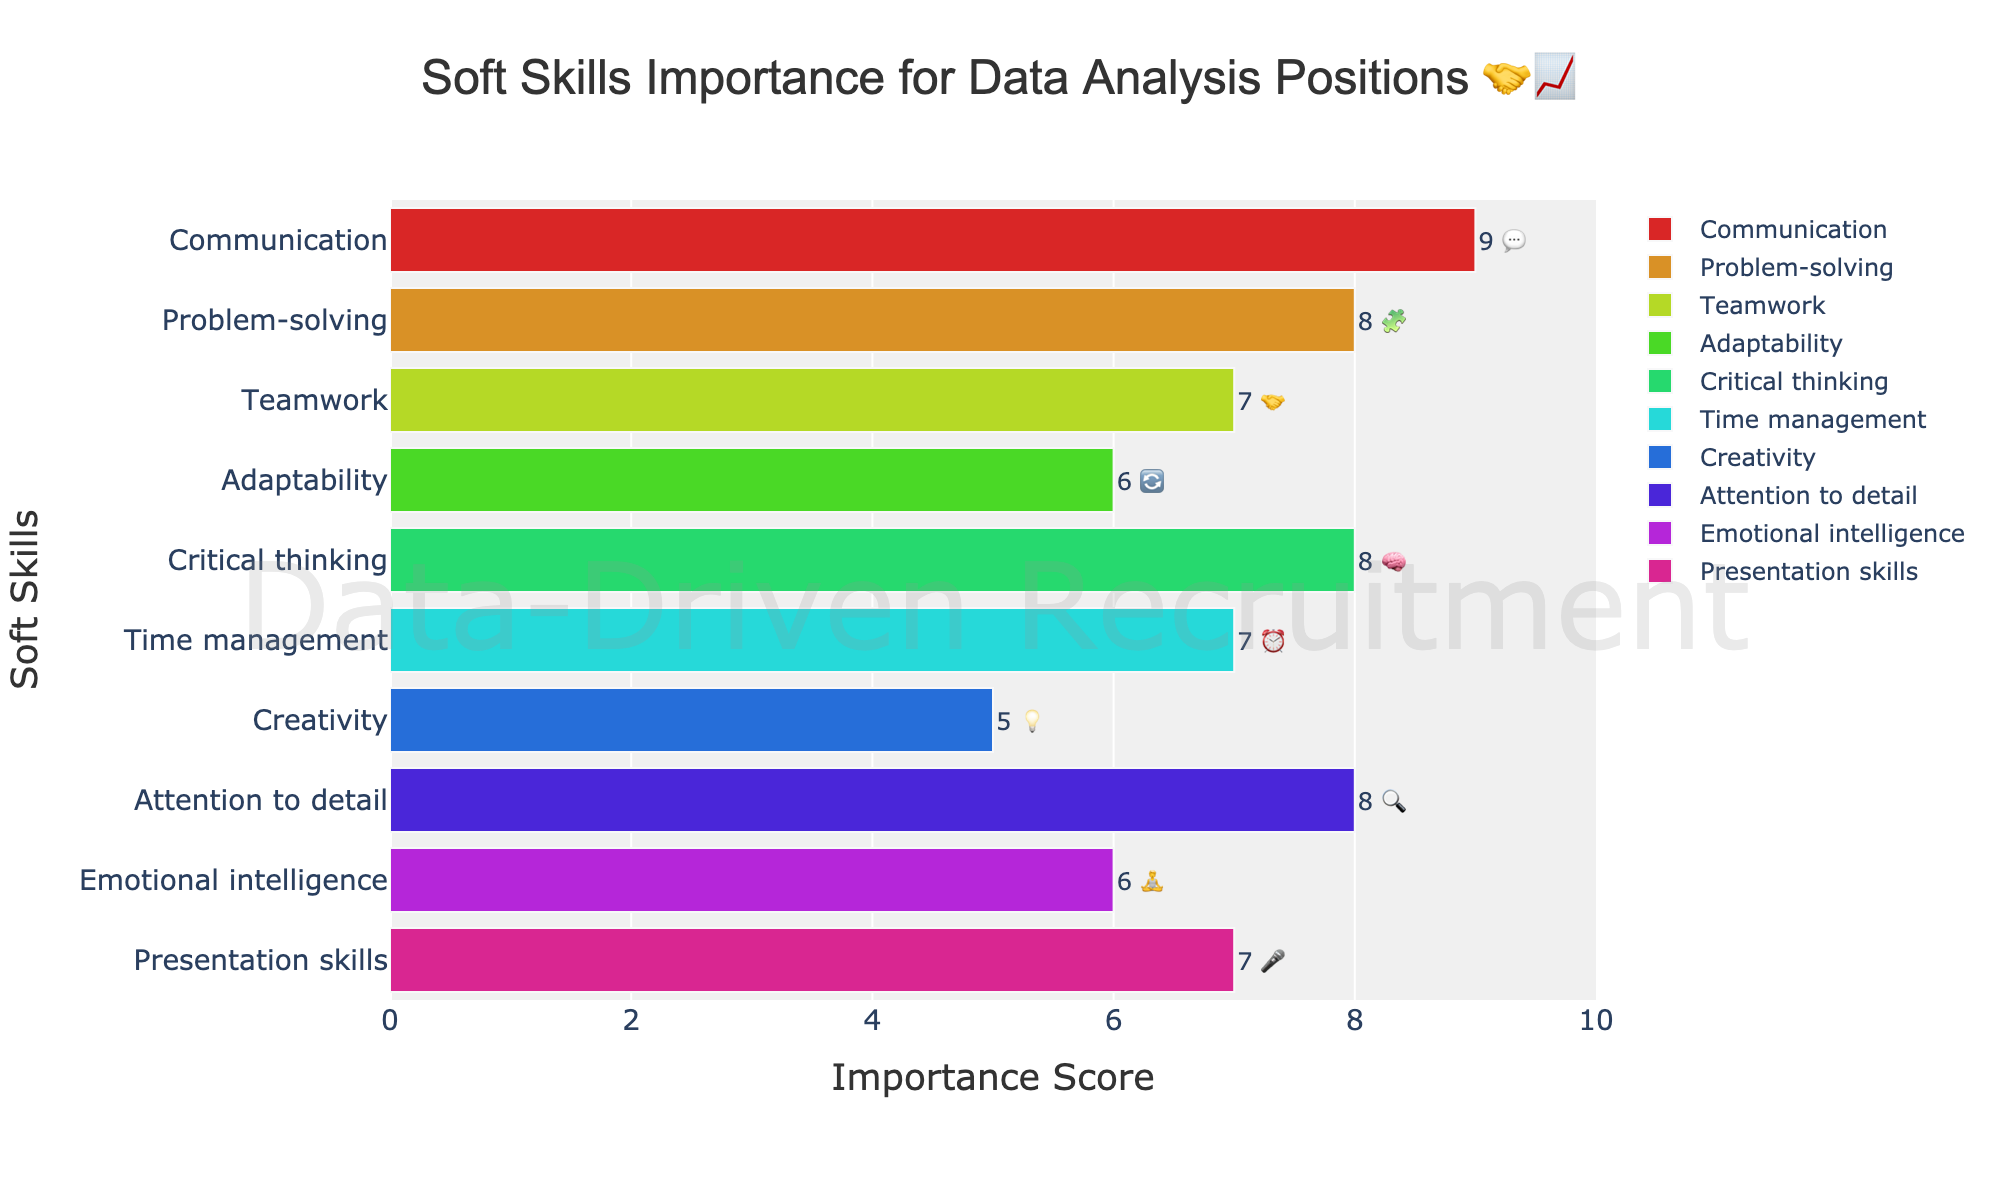How many soft skills are ranked in the chart? Count the number of bars in the chart, each representing a different soft skill
Answer: 10 Which soft skill is considered the most important? Look for the bar with the highest importance score; it's marked with "9 💬"
Answer: Communication Which soft skills have the same importance score and what is that score? Identify the bars with the same importance score in the chart. The ones sharing the same score are "Problem-solving (8)", "Critical thinking (8)", and "Attention to detail (8)"
Answer: Problem-solving, Critical thinking, Attention to detail; 8 What is the difference in the importance score between Creativity and Time management? Subtract the importance score of Creativity (5) from that of Time management (7)
Answer: 2 Which skill has the lowest importance score, and what emoji represents it? Look for the skill with the smallest bar; it has an importance score of 5, marked with "💡"
Answer: Creativity, 💡 Which soft skill is ranked higher: Adaptability or Emotional intelligence? Compare the two bars marked with "6", Adaptability is positioned higher than Emotional intelligence
Answer: Adaptability What is the median importance score of the soft skills listed? Order the importance scores and find the middle value. Ordered scores: 5, 6, 6, 7, 7, 7, 8, 8, 8, 9. Median: (7+7)/2 = 7
Answer: 7 By how much does the importance score of Presentation skills differ from Problem-solving? Subtract the importance score of Presentation skills (7) from that of Problem-solving (8)
Answer: 1 Which color shade does the "Attention to detail" bar have? The bar color follows a spectrum. "Attention to detail" is in a spectrum of green (hover to see or decode the pattern for precise spectrum allocation)
Answer: A shade of green What is the sum of the importance scores for all the soft skills combined? Add all the scores: 9 + 8 + 7 + 6 + 8 + 7 + 5 + 8 + 6 + 7 = 71
Answer: 71 